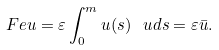<formula> <loc_0><loc_0><loc_500><loc_500>\ F e u = \varepsilon \int _ { 0 } ^ { m } u ( s ) \, \ u d s = \varepsilon \bar { u } .</formula> 